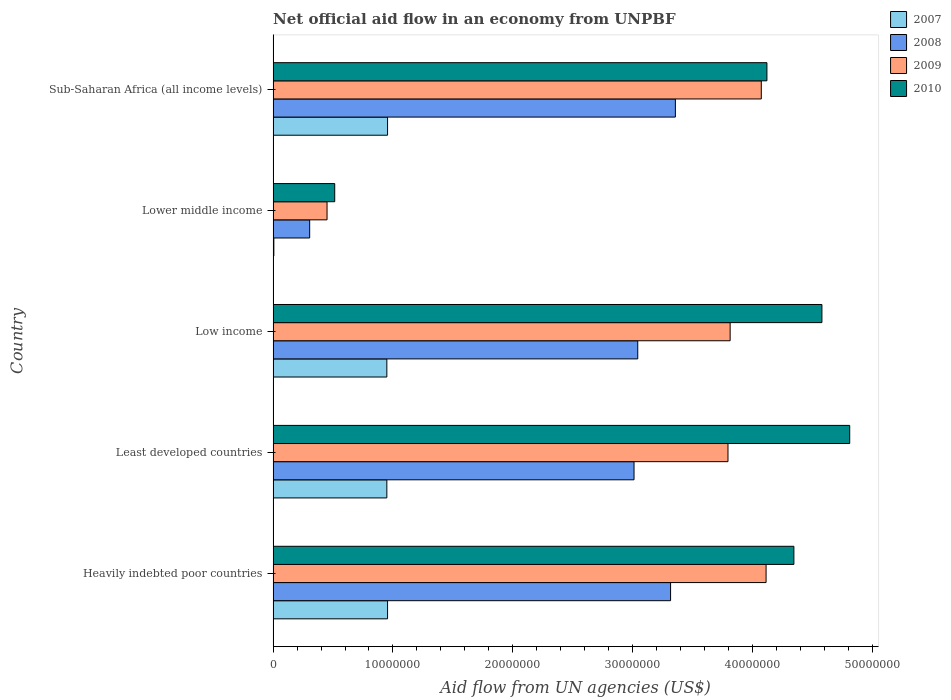How many different coloured bars are there?
Your response must be concise. 4. How many groups of bars are there?
Offer a terse response. 5. Are the number of bars per tick equal to the number of legend labels?
Offer a very short reply. Yes. Are the number of bars on each tick of the Y-axis equal?
Provide a succinct answer. Yes. How many bars are there on the 2nd tick from the bottom?
Offer a terse response. 4. What is the label of the 5th group of bars from the top?
Your answer should be compact. Heavily indebted poor countries. In how many cases, is the number of bars for a given country not equal to the number of legend labels?
Make the answer very short. 0. What is the net official aid flow in 2009 in Sub-Saharan Africa (all income levels)?
Your answer should be compact. 4.07e+07. Across all countries, what is the maximum net official aid flow in 2009?
Provide a short and direct response. 4.11e+07. Across all countries, what is the minimum net official aid flow in 2009?
Your answer should be compact. 4.50e+06. In which country was the net official aid flow in 2008 maximum?
Ensure brevity in your answer.  Sub-Saharan Africa (all income levels). In which country was the net official aid flow in 2010 minimum?
Keep it short and to the point. Lower middle income. What is the total net official aid flow in 2010 in the graph?
Your response must be concise. 1.84e+08. What is the difference between the net official aid flow in 2008 in Heavily indebted poor countries and that in Low income?
Your answer should be very brief. 2.74e+06. What is the difference between the net official aid flow in 2010 in Least developed countries and the net official aid flow in 2007 in Low income?
Offer a very short reply. 3.86e+07. What is the average net official aid flow in 2007 per country?
Give a very brief answer. 7.63e+06. What is the difference between the net official aid flow in 2010 and net official aid flow in 2008 in Least developed countries?
Provide a succinct answer. 1.80e+07. What is the ratio of the net official aid flow in 2010 in Least developed countries to that in Low income?
Ensure brevity in your answer.  1.05. Is the difference between the net official aid flow in 2010 in Heavily indebted poor countries and Least developed countries greater than the difference between the net official aid flow in 2008 in Heavily indebted poor countries and Least developed countries?
Your answer should be compact. No. What is the difference between the highest and the second highest net official aid flow in 2008?
Give a very brief answer. 4.00e+05. What is the difference between the highest and the lowest net official aid flow in 2007?
Your answer should be compact. 9.49e+06. Is the sum of the net official aid flow in 2009 in Least developed countries and Lower middle income greater than the maximum net official aid flow in 2010 across all countries?
Keep it short and to the point. No. What does the 3rd bar from the top in Lower middle income represents?
Provide a short and direct response. 2008. How many bars are there?
Keep it short and to the point. 20. Are all the bars in the graph horizontal?
Provide a succinct answer. Yes. Are the values on the major ticks of X-axis written in scientific E-notation?
Your answer should be compact. No. Does the graph contain any zero values?
Your response must be concise. No. Does the graph contain grids?
Provide a short and direct response. No. How many legend labels are there?
Provide a short and direct response. 4. How are the legend labels stacked?
Ensure brevity in your answer.  Vertical. What is the title of the graph?
Provide a short and direct response. Net official aid flow in an economy from UNPBF. What is the label or title of the X-axis?
Give a very brief answer. Aid flow from UN agencies (US$). What is the label or title of the Y-axis?
Keep it short and to the point. Country. What is the Aid flow from UN agencies (US$) in 2007 in Heavily indebted poor countries?
Give a very brief answer. 9.55e+06. What is the Aid flow from UN agencies (US$) of 2008 in Heavily indebted poor countries?
Provide a short and direct response. 3.32e+07. What is the Aid flow from UN agencies (US$) of 2009 in Heavily indebted poor countries?
Your answer should be very brief. 4.11e+07. What is the Aid flow from UN agencies (US$) in 2010 in Heavily indebted poor countries?
Offer a terse response. 4.35e+07. What is the Aid flow from UN agencies (US$) of 2007 in Least developed countries?
Give a very brief answer. 9.49e+06. What is the Aid flow from UN agencies (US$) of 2008 in Least developed countries?
Your answer should be very brief. 3.01e+07. What is the Aid flow from UN agencies (US$) in 2009 in Least developed countries?
Provide a succinct answer. 3.80e+07. What is the Aid flow from UN agencies (US$) of 2010 in Least developed countries?
Provide a short and direct response. 4.81e+07. What is the Aid flow from UN agencies (US$) of 2007 in Low income?
Provide a short and direct response. 9.49e+06. What is the Aid flow from UN agencies (US$) of 2008 in Low income?
Provide a succinct answer. 3.04e+07. What is the Aid flow from UN agencies (US$) in 2009 in Low income?
Provide a succinct answer. 3.81e+07. What is the Aid flow from UN agencies (US$) in 2010 in Low income?
Keep it short and to the point. 4.58e+07. What is the Aid flow from UN agencies (US$) of 2008 in Lower middle income?
Make the answer very short. 3.05e+06. What is the Aid flow from UN agencies (US$) in 2009 in Lower middle income?
Ensure brevity in your answer.  4.50e+06. What is the Aid flow from UN agencies (US$) of 2010 in Lower middle income?
Your answer should be very brief. 5.14e+06. What is the Aid flow from UN agencies (US$) in 2007 in Sub-Saharan Africa (all income levels)?
Keep it short and to the point. 9.55e+06. What is the Aid flow from UN agencies (US$) of 2008 in Sub-Saharan Africa (all income levels)?
Give a very brief answer. 3.36e+07. What is the Aid flow from UN agencies (US$) in 2009 in Sub-Saharan Africa (all income levels)?
Make the answer very short. 4.07e+07. What is the Aid flow from UN agencies (US$) in 2010 in Sub-Saharan Africa (all income levels)?
Offer a very short reply. 4.12e+07. Across all countries, what is the maximum Aid flow from UN agencies (US$) in 2007?
Your answer should be compact. 9.55e+06. Across all countries, what is the maximum Aid flow from UN agencies (US$) of 2008?
Offer a terse response. 3.36e+07. Across all countries, what is the maximum Aid flow from UN agencies (US$) in 2009?
Your answer should be very brief. 4.11e+07. Across all countries, what is the maximum Aid flow from UN agencies (US$) of 2010?
Your answer should be compact. 4.81e+07. Across all countries, what is the minimum Aid flow from UN agencies (US$) of 2008?
Make the answer very short. 3.05e+06. Across all countries, what is the minimum Aid flow from UN agencies (US$) of 2009?
Ensure brevity in your answer.  4.50e+06. Across all countries, what is the minimum Aid flow from UN agencies (US$) in 2010?
Offer a terse response. 5.14e+06. What is the total Aid flow from UN agencies (US$) in 2007 in the graph?
Give a very brief answer. 3.81e+07. What is the total Aid flow from UN agencies (US$) in 2008 in the graph?
Keep it short and to the point. 1.30e+08. What is the total Aid flow from UN agencies (US$) of 2009 in the graph?
Offer a terse response. 1.62e+08. What is the total Aid flow from UN agencies (US$) in 2010 in the graph?
Ensure brevity in your answer.  1.84e+08. What is the difference between the Aid flow from UN agencies (US$) in 2007 in Heavily indebted poor countries and that in Least developed countries?
Offer a very short reply. 6.00e+04. What is the difference between the Aid flow from UN agencies (US$) in 2008 in Heavily indebted poor countries and that in Least developed countries?
Provide a short and direct response. 3.05e+06. What is the difference between the Aid flow from UN agencies (US$) in 2009 in Heavily indebted poor countries and that in Least developed countries?
Your answer should be very brief. 3.18e+06. What is the difference between the Aid flow from UN agencies (US$) of 2010 in Heavily indebted poor countries and that in Least developed countries?
Offer a terse response. -4.66e+06. What is the difference between the Aid flow from UN agencies (US$) in 2007 in Heavily indebted poor countries and that in Low income?
Make the answer very short. 6.00e+04. What is the difference between the Aid flow from UN agencies (US$) in 2008 in Heavily indebted poor countries and that in Low income?
Your answer should be compact. 2.74e+06. What is the difference between the Aid flow from UN agencies (US$) in 2010 in Heavily indebted poor countries and that in Low income?
Your response must be concise. -2.34e+06. What is the difference between the Aid flow from UN agencies (US$) in 2007 in Heavily indebted poor countries and that in Lower middle income?
Offer a terse response. 9.49e+06. What is the difference between the Aid flow from UN agencies (US$) in 2008 in Heavily indebted poor countries and that in Lower middle income?
Offer a terse response. 3.01e+07. What is the difference between the Aid flow from UN agencies (US$) in 2009 in Heavily indebted poor countries and that in Lower middle income?
Your answer should be compact. 3.66e+07. What is the difference between the Aid flow from UN agencies (US$) of 2010 in Heavily indebted poor countries and that in Lower middle income?
Make the answer very short. 3.83e+07. What is the difference between the Aid flow from UN agencies (US$) of 2008 in Heavily indebted poor countries and that in Sub-Saharan Africa (all income levels)?
Give a very brief answer. -4.00e+05. What is the difference between the Aid flow from UN agencies (US$) in 2009 in Heavily indebted poor countries and that in Sub-Saharan Africa (all income levels)?
Your answer should be very brief. 4.00e+05. What is the difference between the Aid flow from UN agencies (US$) of 2010 in Heavily indebted poor countries and that in Sub-Saharan Africa (all income levels)?
Your answer should be very brief. 2.25e+06. What is the difference between the Aid flow from UN agencies (US$) in 2007 in Least developed countries and that in Low income?
Provide a succinct answer. 0. What is the difference between the Aid flow from UN agencies (US$) in 2008 in Least developed countries and that in Low income?
Make the answer very short. -3.10e+05. What is the difference between the Aid flow from UN agencies (US$) of 2009 in Least developed countries and that in Low income?
Offer a very short reply. -1.80e+05. What is the difference between the Aid flow from UN agencies (US$) in 2010 in Least developed countries and that in Low income?
Make the answer very short. 2.32e+06. What is the difference between the Aid flow from UN agencies (US$) in 2007 in Least developed countries and that in Lower middle income?
Make the answer very short. 9.43e+06. What is the difference between the Aid flow from UN agencies (US$) of 2008 in Least developed countries and that in Lower middle income?
Make the answer very short. 2.71e+07. What is the difference between the Aid flow from UN agencies (US$) of 2009 in Least developed countries and that in Lower middle income?
Give a very brief answer. 3.35e+07. What is the difference between the Aid flow from UN agencies (US$) of 2010 in Least developed countries and that in Lower middle income?
Keep it short and to the point. 4.30e+07. What is the difference between the Aid flow from UN agencies (US$) of 2007 in Least developed countries and that in Sub-Saharan Africa (all income levels)?
Offer a very short reply. -6.00e+04. What is the difference between the Aid flow from UN agencies (US$) of 2008 in Least developed countries and that in Sub-Saharan Africa (all income levels)?
Your answer should be compact. -3.45e+06. What is the difference between the Aid flow from UN agencies (US$) in 2009 in Least developed countries and that in Sub-Saharan Africa (all income levels)?
Your answer should be compact. -2.78e+06. What is the difference between the Aid flow from UN agencies (US$) of 2010 in Least developed countries and that in Sub-Saharan Africa (all income levels)?
Provide a short and direct response. 6.91e+06. What is the difference between the Aid flow from UN agencies (US$) in 2007 in Low income and that in Lower middle income?
Offer a very short reply. 9.43e+06. What is the difference between the Aid flow from UN agencies (US$) of 2008 in Low income and that in Lower middle income?
Your response must be concise. 2.74e+07. What is the difference between the Aid flow from UN agencies (US$) of 2009 in Low income and that in Lower middle income?
Provide a short and direct response. 3.36e+07. What is the difference between the Aid flow from UN agencies (US$) of 2010 in Low income and that in Lower middle income?
Offer a very short reply. 4.07e+07. What is the difference between the Aid flow from UN agencies (US$) in 2008 in Low income and that in Sub-Saharan Africa (all income levels)?
Offer a very short reply. -3.14e+06. What is the difference between the Aid flow from UN agencies (US$) of 2009 in Low income and that in Sub-Saharan Africa (all income levels)?
Your answer should be very brief. -2.60e+06. What is the difference between the Aid flow from UN agencies (US$) of 2010 in Low income and that in Sub-Saharan Africa (all income levels)?
Provide a short and direct response. 4.59e+06. What is the difference between the Aid flow from UN agencies (US$) in 2007 in Lower middle income and that in Sub-Saharan Africa (all income levels)?
Your answer should be very brief. -9.49e+06. What is the difference between the Aid flow from UN agencies (US$) of 2008 in Lower middle income and that in Sub-Saharan Africa (all income levels)?
Offer a terse response. -3.05e+07. What is the difference between the Aid flow from UN agencies (US$) of 2009 in Lower middle income and that in Sub-Saharan Africa (all income levels)?
Provide a succinct answer. -3.62e+07. What is the difference between the Aid flow from UN agencies (US$) in 2010 in Lower middle income and that in Sub-Saharan Africa (all income levels)?
Your response must be concise. -3.61e+07. What is the difference between the Aid flow from UN agencies (US$) of 2007 in Heavily indebted poor countries and the Aid flow from UN agencies (US$) of 2008 in Least developed countries?
Offer a very short reply. -2.06e+07. What is the difference between the Aid flow from UN agencies (US$) in 2007 in Heavily indebted poor countries and the Aid flow from UN agencies (US$) in 2009 in Least developed countries?
Offer a terse response. -2.84e+07. What is the difference between the Aid flow from UN agencies (US$) in 2007 in Heavily indebted poor countries and the Aid flow from UN agencies (US$) in 2010 in Least developed countries?
Your answer should be very brief. -3.86e+07. What is the difference between the Aid flow from UN agencies (US$) of 2008 in Heavily indebted poor countries and the Aid flow from UN agencies (US$) of 2009 in Least developed countries?
Give a very brief answer. -4.79e+06. What is the difference between the Aid flow from UN agencies (US$) in 2008 in Heavily indebted poor countries and the Aid flow from UN agencies (US$) in 2010 in Least developed countries?
Ensure brevity in your answer.  -1.50e+07. What is the difference between the Aid flow from UN agencies (US$) of 2009 in Heavily indebted poor countries and the Aid flow from UN agencies (US$) of 2010 in Least developed countries?
Offer a very short reply. -6.98e+06. What is the difference between the Aid flow from UN agencies (US$) in 2007 in Heavily indebted poor countries and the Aid flow from UN agencies (US$) in 2008 in Low income?
Ensure brevity in your answer.  -2.09e+07. What is the difference between the Aid flow from UN agencies (US$) in 2007 in Heavily indebted poor countries and the Aid flow from UN agencies (US$) in 2009 in Low income?
Offer a very short reply. -2.86e+07. What is the difference between the Aid flow from UN agencies (US$) of 2007 in Heavily indebted poor countries and the Aid flow from UN agencies (US$) of 2010 in Low income?
Keep it short and to the point. -3.62e+07. What is the difference between the Aid flow from UN agencies (US$) of 2008 in Heavily indebted poor countries and the Aid flow from UN agencies (US$) of 2009 in Low income?
Your answer should be compact. -4.97e+06. What is the difference between the Aid flow from UN agencies (US$) of 2008 in Heavily indebted poor countries and the Aid flow from UN agencies (US$) of 2010 in Low income?
Keep it short and to the point. -1.26e+07. What is the difference between the Aid flow from UN agencies (US$) of 2009 in Heavily indebted poor countries and the Aid flow from UN agencies (US$) of 2010 in Low income?
Ensure brevity in your answer.  -4.66e+06. What is the difference between the Aid flow from UN agencies (US$) of 2007 in Heavily indebted poor countries and the Aid flow from UN agencies (US$) of 2008 in Lower middle income?
Your answer should be very brief. 6.50e+06. What is the difference between the Aid flow from UN agencies (US$) of 2007 in Heavily indebted poor countries and the Aid flow from UN agencies (US$) of 2009 in Lower middle income?
Your answer should be compact. 5.05e+06. What is the difference between the Aid flow from UN agencies (US$) in 2007 in Heavily indebted poor countries and the Aid flow from UN agencies (US$) in 2010 in Lower middle income?
Your answer should be very brief. 4.41e+06. What is the difference between the Aid flow from UN agencies (US$) in 2008 in Heavily indebted poor countries and the Aid flow from UN agencies (US$) in 2009 in Lower middle income?
Offer a terse response. 2.87e+07. What is the difference between the Aid flow from UN agencies (US$) of 2008 in Heavily indebted poor countries and the Aid flow from UN agencies (US$) of 2010 in Lower middle income?
Ensure brevity in your answer.  2.80e+07. What is the difference between the Aid flow from UN agencies (US$) of 2009 in Heavily indebted poor countries and the Aid flow from UN agencies (US$) of 2010 in Lower middle income?
Your answer should be compact. 3.60e+07. What is the difference between the Aid flow from UN agencies (US$) in 2007 in Heavily indebted poor countries and the Aid flow from UN agencies (US$) in 2008 in Sub-Saharan Africa (all income levels)?
Ensure brevity in your answer.  -2.40e+07. What is the difference between the Aid flow from UN agencies (US$) in 2007 in Heavily indebted poor countries and the Aid flow from UN agencies (US$) in 2009 in Sub-Saharan Africa (all income levels)?
Make the answer very short. -3.12e+07. What is the difference between the Aid flow from UN agencies (US$) in 2007 in Heavily indebted poor countries and the Aid flow from UN agencies (US$) in 2010 in Sub-Saharan Africa (all income levels)?
Provide a succinct answer. -3.17e+07. What is the difference between the Aid flow from UN agencies (US$) in 2008 in Heavily indebted poor countries and the Aid flow from UN agencies (US$) in 2009 in Sub-Saharan Africa (all income levels)?
Your answer should be compact. -7.57e+06. What is the difference between the Aid flow from UN agencies (US$) in 2008 in Heavily indebted poor countries and the Aid flow from UN agencies (US$) in 2010 in Sub-Saharan Africa (all income levels)?
Offer a terse response. -8.04e+06. What is the difference between the Aid flow from UN agencies (US$) of 2009 in Heavily indebted poor countries and the Aid flow from UN agencies (US$) of 2010 in Sub-Saharan Africa (all income levels)?
Your answer should be very brief. -7.00e+04. What is the difference between the Aid flow from UN agencies (US$) in 2007 in Least developed countries and the Aid flow from UN agencies (US$) in 2008 in Low income?
Provide a succinct answer. -2.09e+07. What is the difference between the Aid flow from UN agencies (US$) in 2007 in Least developed countries and the Aid flow from UN agencies (US$) in 2009 in Low income?
Give a very brief answer. -2.86e+07. What is the difference between the Aid flow from UN agencies (US$) of 2007 in Least developed countries and the Aid flow from UN agencies (US$) of 2010 in Low income?
Ensure brevity in your answer.  -3.63e+07. What is the difference between the Aid flow from UN agencies (US$) of 2008 in Least developed countries and the Aid flow from UN agencies (US$) of 2009 in Low income?
Make the answer very short. -8.02e+06. What is the difference between the Aid flow from UN agencies (US$) in 2008 in Least developed countries and the Aid flow from UN agencies (US$) in 2010 in Low income?
Keep it short and to the point. -1.57e+07. What is the difference between the Aid flow from UN agencies (US$) of 2009 in Least developed countries and the Aid flow from UN agencies (US$) of 2010 in Low income?
Provide a succinct answer. -7.84e+06. What is the difference between the Aid flow from UN agencies (US$) in 2007 in Least developed countries and the Aid flow from UN agencies (US$) in 2008 in Lower middle income?
Give a very brief answer. 6.44e+06. What is the difference between the Aid flow from UN agencies (US$) of 2007 in Least developed countries and the Aid flow from UN agencies (US$) of 2009 in Lower middle income?
Your answer should be compact. 4.99e+06. What is the difference between the Aid flow from UN agencies (US$) in 2007 in Least developed countries and the Aid flow from UN agencies (US$) in 2010 in Lower middle income?
Offer a terse response. 4.35e+06. What is the difference between the Aid flow from UN agencies (US$) of 2008 in Least developed countries and the Aid flow from UN agencies (US$) of 2009 in Lower middle income?
Offer a very short reply. 2.56e+07. What is the difference between the Aid flow from UN agencies (US$) of 2008 in Least developed countries and the Aid flow from UN agencies (US$) of 2010 in Lower middle income?
Give a very brief answer. 2.50e+07. What is the difference between the Aid flow from UN agencies (US$) in 2009 in Least developed countries and the Aid flow from UN agencies (US$) in 2010 in Lower middle income?
Make the answer very short. 3.28e+07. What is the difference between the Aid flow from UN agencies (US$) in 2007 in Least developed countries and the Aid flow from UN agencies (US$) in 2008 in Sub-Saharan Africa (all income levels)?
Your answer should be compact. -2.41e+07. What is the difference between the Aid flow from UN agencies (US$) in 2007 in Least developed countries and the Aid flow from UN agencies (US$) in 2009 in Sub-Saharan Africa (all income levels)?
Your answer should be very brief. -3.12e+07. What is the difference between the Aid flow from UN agencies (US$) in 2007 in Least developed countries and the Aid flow from UN agencies (US$) in 2010 in Sub-Saharan Africa (all income levels)?
Ensure brevity in your answer.  -3.17e+07. What is the difference between the Aid flow from UN agencies (US$) of 2008 in Least developed countries and the Aid flow from UN agencies (US$) of 2009 in Sub-Saharan Africa (all income levels)?
Your response must be concise. -1.06e+07. What is the difference between the Aid flow from UN agencies (US$) of 2008 in Least developed countries and the Aid flow from UN agencies (US$) of 2010 in Sub-Saharan Africa (all income levels)?
Your response must be concise. -1.11e+07. What is the difference between the Aid flow from UN agencies (US$) of 2009 in Least developed countries and the Aid flow from UN agencies (US$) of 2010 in Sub-Saharan Africa (all income levels)?
Your answer should be compact. -3.25e+06. What is the difference between the Aid flow from UN agencies (US$) in 2007 in Low income and the Aid flow from UN agencies (US$) in 2008 in Lower middle income?
Your answer should be very brief. 6.44e+06. What is the difference between the Aid flow from UN agencies (US$) of 2007 in Low income and the Aid flow from UN agencies (US$) of 2009 in Lower middle income?
Ensure brevity in your answer.  4.99e+06. What is the difference between the Aid flow from UN agencies (US$) of 2007 in Low income and the Aid flow from UN agencies (US$) of 2010 in Lower middle income?
Your answer should be very brief. 4.35e+06. What is the difference between the Aid flow from UN agencies (US$) in 2008 in Low income and the Aid flow from UN agencies (US$) in 2009 in Lower middle income?
Provide a short and direct response. 2.59e+07. What is the difference between the Aid flow from UN agencies (US$) in 2008 in Low income and the Aid flow from UN agencies (US$) in 2010 in Lower middle income?
Keep it short and to the point. 2.53e+07. What is the difference between the Aid flow from UN agencies (US$) of 2009 in Low income and the Aid flow from UN agencies (US$) of 2010 in Lower middle income?
Your answer should be very brief. 3.30e+07. What is the difference between the Aid flow from UN agencies (US$) of 2007 in Low income and the Aid flow from UN agencies (US$) of 2008 in Sub-Saharan Africa (all income levels)?
Give a very brief answer. -2.41e+07. What is the difference between the Aid flow from UN agencies (US$) of 2007 in Low income and the Aid flow from UN agencies (US$) of 2009 in Sub-Saharan Africa (all income levels)?
Your answer should be very brief. -3.12e+07. What is the difference between the Aid flow from UN agencies (US$) in 2007 in Low income and the Aid flow from UN agencies (US$) in 2010 in Sub-Saharan Africa (all income levels)?
Make the answer very short. -3.17e+07. What is the difference between the Aid flow from UN agencies (US$) of 2008 in Low income and the Aid flow from UN agencies (US$) of 2009 in Sub-Saharan Africa (all income levels)?
Your answer should be compact. -1.03e+07. What is the difference between the Aid flow from UN agencies (US$) of 2008 in Low income and the Aid flow from UN agencies (US$) of 2010 in Sub-Saharan Africa (all income levels)?
Your response must be concise. -1.08e+07. What is the difference between the Aid flow from UN agencies (US$) in 2009 in Low income and the Aid flow from UN agencies (US$) in 2010 in Sub-Saharan Africa (all income levels)?
Provide a succinct answer. -3.07e+06. What is the difference between the Aid flow from UN agencies (US$) in 2007 in Lower middle income and the Aid flow from UN agencies (US$) in 2008 in Sub-Saharan Africa (all income levels)?
Ensure brevity in your answer.  -3.35e+07. What is the difference between the Aid flow from UN agencies (US$) in 2007 in Lower middle income and the Aid flow from UN agencies (US$) in 2009 in Sub-Saharan Africa (all income levels)?
Your response must be concise. -4.07e+07. What is the difference between the Aid flow from UN agencies (US$) in 2007 in Lower middle income and the Aid flow from UN agencies (US$) in 2010 in Sub-Saharan Africa (all income levels)?
Give a very brief answer. -4.12e+07. What is the difference between the Aid flow from UN agencies (US$) in 2008 in Lower middle income and the Aid flow from UN agencies (US$) in 2009 in Sub-Saharan Africa (all income levels)?
Your answer should be very brief. -3.77e+07. What is the difference between the Aid flow from UN agencies (US$) of 2008 in Lower middle income and the Aid flow from UN agencies (US$) of 2010 in Sub-Saharan Africa (all income levels)?
Provide a short and direct response. -3.82e+07. What is the difference between the Aid flow from UN agencies (US$) of 2009 in Lower middle income and the Aid flow from UN agencies (US$) of 2010 in Sub-Saharan Africa (all income levels)?
Your answer should be compact. -3.67e+07. What is the average Aid flow from UN agencies (US$) of 2007 per country?
Give a very brief answer. 7.63e+06. What is the average Aid flow from UN agencies (US$) in 2008 per country?
Offer a very short reply. 2.61e+07. What is the average Aid flow from UN agencies (US$) of 2009 per country?
Offer a terse response. 3.25e+07. What is the average Aid flow from UN agencies (US$) in 2010 per country?
Your answer should be very brief. 3.67e+07. What is the difference between the Aid flow from UN agencies (US$) in 2007 and Aid flow from UN agencies (US$) in 2008 in Heavily indebted poor countries?
Give a very brief answer. -2.36e+07. What is the difference between the Aid flow from UN agencies (US$) in 2007 and Aid flow from UN agencies (US$) in 2009 in Heavily indebted poor countries?
Offer a very short reply. -3.16e+07. What is the difference between the Aid flow from UN agencies (US$) of 2007 and Aid flow from UN agencies (US$) of 2010 in Heavily indebted poor countries?
Make the answer very short. -3.39e+07. What is the difference between the Aid flow from UN agencies (US$) of 2008 and Aid flow from UN agencies (US$) of 2009 in Heavily indebted poor countries?
Your answer should be very brief. -7.97e+06. What is the difference between the Aid flow from UN agencies (US$) in 2008 and Aid flow from UN agencies (US$) in 2010 in Heavily indebted poor countries?
Provide a short and direct response. -1.03e+07. What is the difference between the Aid flow from UN agencies (US$) in 2009 and Aid flow from UN agencies (US$) in 2010 in Heavily indebted poor countries?
Make the answer very short. -2.32e+06. What is the difference between the Aid flow from UN agencies (US$) in 2007 and Aid flow from UN agencies (US$) in 2008 in Least developed countries?
Your response must be concise. -2.06e+07. What is the difference between the Aid flow from UN agencies (US$) of 2007 and Aid flow from UN agencies (US$) of 2009 in Least developed countries?
Provide a succinct answer. -2.85e+07. What is the difference between the Aid flow from UN agencies (US$) of 2007 and Aid flow from UN agencies (US$) of 2010 in Least developed countries?
Give a very brief answer. -3.86e+07. What is the difference between the Aid flow from UN agencies (US$) of 2008 and Aid flow from UN agencies (US$) of 2009 in Least developed countries?
Ensure brevity in your answer.  -7.84e+06. What is the difference between the Aid flow from UN agencies (US$) in 2008 and Aid flow from UN agencies (US$) in 2010 in Least developed countries?
Make the answer very short. -1.80e+07. What is the difference between the Aid flow from UN agencies (US$) in 2009 and Aid flow from UN agencies (US$) in 2010 in Least developed countries?
Offer a terse response. -1.02e+07. What is the difference between the Aid flow from UN agencies (US$) in 2007 and Aid flow from UN agencies (US$) in 2008 in Low income?
Your answer should be compact. -2.09e+07. What is the difference between the Aid flow from UN agencies (US$) of 2007 and Aid flow from UN agencies (US$) of 2009 in Low income?
Your answer should be very brief. -2.86e+07. What is the difference between the Aid flow from UN agencies (US$) in 2007 and Aid flow from UN agencies (US$) in 2010 in Low income?
Your response must be concise. -3.63e+07. What is the difference between the Aid flow from UN agencies (US$) of 2008 and Aid flow from UN agencies (US$) of 2009 in Low income?
Make the answer very short. -7.71e+06. What is the difference between the Aid flow from UN agencies (US$) in 2008 and Aid flow from UN agencies (US$) in 2010 in Low income?
Offer a very short reply. -1.54e+07. What is the difference between the Aid flow from UN agencies (US$) in 2009 and Aid flow from UN agencies (US$) in 2010 in Low income?
Give a very brief answer. -7.66e+06. What is the difference between the Aid flow from UN agencies (US$) in 2007 and Aid flow from UN agencies (US$) in 2008 in Lower middle income?
Offer a very short reply. -2.99e+06. What is the difference between the Aid flow from UN agencies (US$) in 2007 and Aid flow from UN agencies (US$) in 2009 in Lower middle income?
Offer a very short reply. -4.44e+06. What is the difference between the Aid flow from UN agencies (US$) of 2007 and Aid flow from UN agencies (US$) of 2010 in Lower middle income?
Make the answer very short. -5.08e+06. What is the difference between the Aid flow from UN agencies (US$) of 2008 and Aid flow from UN agencies (US$) of 2009 in Lower middle income?
Provide a short and direct response. -1.45e+06. What is the difference between the Aid flow from UN agencies (US$) of 2008 and Aid flow from UN agencies (US$) of 2010 in Lower middle income?
Your answer should be compact. -2.09e+06. What is the difference between the Aid flow from UN agencies (US$) in 2009 and Aid flow from UN agencies (US$) in 2010 in Lower middle income?
Your answer should be compact. -6.40e+05. What is the difference between the Aid flow from UN agencies (US$) of 2007 and Aid flow from UN agencies (US$) of 2008 in Sub-Saharan Africa (all income levels)?
Offer a terse response. -2.40e+07. What is the difference between the Aid flow from UN agencies (US$) in 2007 and Aid flow from UN agencies (US$) in 2009 in Sub-Saharan Africa (all income levels)?
Your answer should be compact. -3.12e+07. What is the difference between the Aid flow from UN agencies (US$) of 2007 and Aid flow from UN agencies (US$) of 2010 in Sub-Saharan Africa (all income levels)?
Offer a very short reply. -3.17e+07. What is the difference between the Aid flow from UN agencies (US$) of 2008 and Aid flow from UN agencies (US$) of 2009 in Sub-Saharan Africa (all income levels)?
Make the answer very short. -7.17e+06. What is the difference between the Aid flow from UN agencies (US$) of 2008 and Aid flow from UN agencies (US$) of 2010 in Sub-Saharan Africa (all income levels)?
Ensure brevity in your answer.  -7.64e+06. What is the difference between the Aid flow from UN agencies (US$) of 2009 and Aid flow from UN agencies (US$) of 2010 in Sub-Saharan Africa (all income levels)?
Ensure brevity in your answer.  -4.70e+05. What is the ratio of the Aid flow from UN agencies (US$) of 2007 in Heavily indebted poor countries to that in Least developed countries?
Ensure brevity in your answer.  1.01. What is the ratio of the Aid flow from UN agencies (US$) of 2008 in Heavily indebted poor countries to that in Least developed countries?
Provide a succinct answer. 1.1. What is the ratio of the Aid flow from UN agencies (US$) in 2009 in Heavily indebted poor countries to that in Least developed countries?
Make the answer very short. 1.08. What is the ratio of the Aid flow from UN agencies (US$) in 2010 in Heavily indebted poor countries to that in Least developed countries?
Offer a terse response. 0.9. What is the ratio of the Aid flow from UN agencies (US$) of 2008 in Heavily indebted poor countries to that in Low income?
Your answer should be very brief. 1.09. What is the ratio of the Aid flow from UN agencies (US$) of 2009 in Heavily indebted poor countries to that in Low income?
Make the answer very short. 1.08. What is the ratio of the Aid flow from UN agencies (US$) of 2010 in Heavily indebted poor countries to that in Low income?
Your response must be concise. 0.95. What is the ratio of the Aid flow from UN agencies (US$) of 2007 in Heavily indebted poor countries to that in Lower middle income?
Offer a very short reply. 159.17. What is the ratio of the Aid flow from UN agencies (US$) in 2008 in Heavily indebted poor countries to that in Lower middle income?
Offer a very short reply. 10.88. What is the ratio of the Aid flow from UN agencies (US$) in 2009 in Heavily indebted poor countries to that in Lower middle income?
Provide a succinct answer. 9.14. What is the ratio of the Aid flow from UN agencies (US$) of 2010 in Heavily indebted poor countries to that in Lower middle income?
Offer a terse response. 8.46. What is the ratio of the Aid flow from UN agencies (US$) of 2007 in Heavily indebted poor countries to that in Sub-Saharan Africa (all income levels)?
Your answer should be compact. 1. What is the ratio of the Aid flow from UN agencies (US$) of 2008 in Heavily indebted poor countries to that in Sub-Saharan Africa (all income levels)?
Offer a very short reply. 0.99. What is the ratio of the Aid flow from UN agencies (US$) in 2009 in Heavily indebted poor countries to that in Sub-Saharan Africa (all income levels)?
Provide a succinct answer. 1.01. What is the ratio of the Aid flow from UN agencies (US$) of 2010 in Heavily indebted poor countries to that in Sub-Saharan Africa (all income levels)?
Give a very brief answer. 1.05. What is the ratio of the Aid flow from UN agencies (US$) in 2007 in Least developed countries to that in Low income?
Your answer should be compact. 1. What is the ratio of the Aid flow from UN agencies (US$) in 2010 in Least developed countries to that in Low income?
Make the answer very short. 1.05. What is the ratio of the Aid flow from UN agencies (US$) in 2007 in Least developed countries to that in Lower middle income?
Give a very brief answer. 158.17. What is the ratio of the Aid flow from UN agencies (US$) of 2008 in Least developed countries to that in Lower middle income?
Offer a very short reply. 9.88. What is the ratio of the Aid flow from UN agencies (US$) in 2009 in Least developed countries to that in Lower middle income?
Offer a terse response. 8.44. What is the ratio of the Aid flow from UN agencies (US$) in 2010 in Least developed countries to that in Lower middle income?
Your answer should be very brief. 9.36. What is the ratio of the Aid flow from UN agencies (US$) in 2008 in Least developed countries to that in Sub-Saharan Africa (all income levels)?
Make the answer very short. 0.9. What is the ratio of the Aid flow from UN agencies (US$) of 2009 in Least developed countries to that in Sub-Saharan Africa (all income levels)?
Ensure brevity in your answer.  0.93. What is the ratio of the Aid flow from UN agencies (US$) in 2010 in Least developed countries to that in Sub-Saharan Africa (all income levels)?
Give a very brief answer. 1.17. What is the ratio of the Aid flow from UN agencies (US$) in 2007 in Low income to that in Lower middle income?
Give a very brief answer. 158.17. What is the ratio of the Aid flow from UN agencies (US$) in 2008 in Low income to that in Lower middle income?
Offer a very short reply. 9.98. What is the ratio of the Aid flow from UN agencies (US$) in 2009 in Low income to that in Lower middle income?
Offer a terse response. 8.48. What is the ratio of the Aid flow from UN agencies (US$) of 2010 in Low income to that in Lower middle income?
Make the answer very short. 8.91. What is the ratio of the Aid flow from UN agencies (US$) of 2007 in Low income to that in Sub-Saharan Africa (all income levels)?
Make the answer very short. 0.99. What is the ratio of the Aid flow from UN agencies (US$) in 2008 in Low income to that in Sub-Saharan Africa (all income levels)?
Make the answer very short. 0.91. What is the ratio of the Aid flow from UN agencies (US$) of 2009 in Low income to that in Sub-Saharan Africa (all income levels)?
Give a very brief answer. 0.94. What is the ratio of the Aid flow from UN agencies (US$) in 2010 in Low income to that in Sub-Saharan Africa (all income levels)?
Offer a terse response. 1.11. What is the ratio of the Aid flow from UN agencies (US$) of 2007 in Lower middle income to that in Sub-Saharan Africa (all income levels)?
Your answer should be very brief. 0.01. What is the ratio of the Aid flow from UN agencies (US$) in 2008 in Lower middle income to that in Sub-Saharan Africa (all income levels)?
Your response must be concise. 0.09. What is the ratio of the Aid flow from UN agencies (US$) of 2009 in Lower middle income to that in Sub-Saharan Africa (all income levels)?
Make the answer very short. 0.11. What is the ratio of the Aid flow from UN agencies (US$) of 2010 in Lower middle income to that in Sub-Saharan Africa (all income levels)?
Make the answer very short. 0.12. What is the difference between the highest and the second highest Aid flow from UN agencies (US$) in 2007?
Keep it short and to the point. 0. What is the difference between the highest and the second highest Aid flow from UN agencies (US$) of 2008?
Offer a very short reply. 4.00e+05. What is the difference between the highest and the second highest Aid flow from UN agencies (US$) of 2010?
Give a very brief answer. 2.32e+06. What is the difference between the highest and the lowest Aid flow from UN agencies (US$) in 2007?
Your response must be concise. 9.49e+06. What is the difference between the highest and the lowest Aid flow from UN agencies (US$) of 2008?
Your response must be concise. 3.05e+07. What is the difference between the highest and the lowest Aid flow from UN agencies (US$) of 2009?
Your response must be concise. 3.66e+07. What is the difference between the highest and the lowest Aid flow from UN agencies (US$) in 2010?
Your answer should be compact. 4.30e+07. 